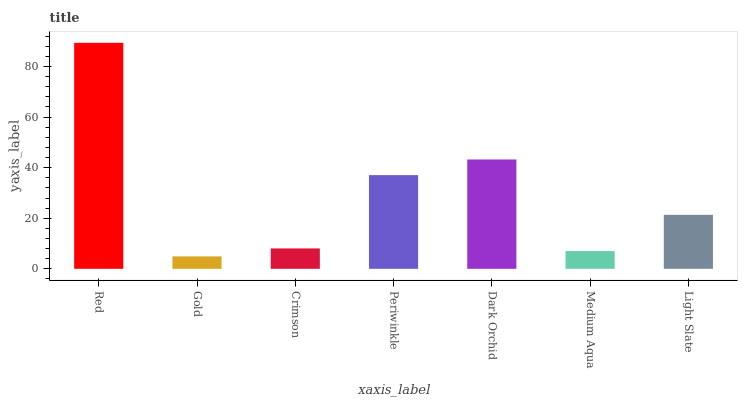Is Gold the minimum?
Answer yes or no. Yes. Is Red the maximum?
Answer yes or no. Yes. Is Crimson the minimum?
Answer yes or no. No. Is Crimson the maximum?
Answer yes or no. No. Is Crimson greater than Gold?
Answer yes or no. Yes. Is Gold less than Crimson?
Answer yes or no. Yes. Is Gold greater than Crimson?
Answer yes or no. No. Is Crimson less than Gold?
Answer yes or no. No. Is Light Slate the high median?
Answer yes or no. Yes. Is Light Slate the low median?
Answer yes or no. Yes. Is Red the high median?
Answer yes or no. No. Is Dark Orchid the low median?
Answer yes or no. No. 